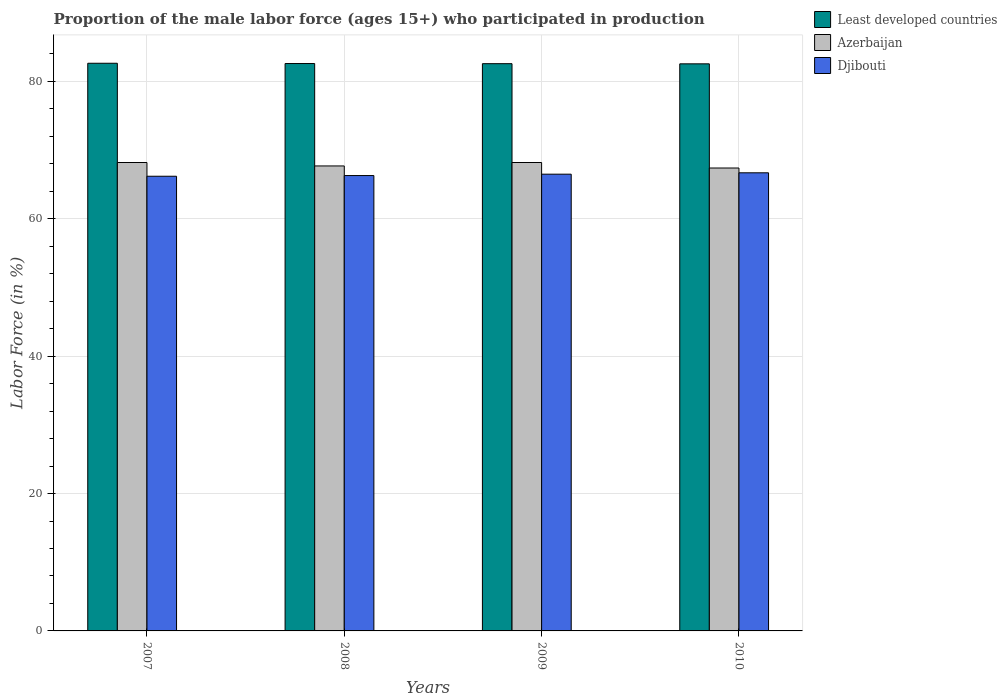How many groups of bars are there?
Provide a short and direct response. 4. Are the number of bars on each tick of the X-axis equal?
Make the answer very short. Yes. How many bars are there on the 1st tick from the left?
Provide a short and direct response. 3. What is the label of the 4th group of bars from the left?
Give a very brief answer. 2010. What is the proportion of the male labor force who participated in production in Least developed countries in 2008?
Provide a succinct answer. 82.61. Across all years, what is the maximum proportion of the male labor force who participated in production in Djibouti?
Keep it short and to the point. 66.7. Across all years, what is the minimum proportion of the male labor force who participated in production in Least developed countries?
Provide a succinct answer. 82.57. What is the total proportion of the male labor force who participated in production in Azerbaijan in the graph?
Ensure brevity in your answer.  271.5. What is the difference between the proportion of the male labor force who participated in production in Djibouti in 2009 and that in 2010?
Make the answer very short. -0.2. What is the difference between the proportion of the male labor force who participated in production in Azerbaijan in 2010 and the proportion of the male labor force who participated in production in Least developed countries in 2009?
Your response must be concise. -15.19. What is the average proportion of the male labor force who participated in production in Azerbaijan per year?
Keep it short and to the point. 67.87. What is the ratio of the proportion of the male labor force who participated in production in Least developed countries in 2007 to that in 2009?
Ensure brevity in your answer.  1. Is the proportion of the male labor force who participated in production in Djibouti in 2007 less than that in 2008?
Offer a terse response. Yes. Is the difference between the proportion of the male labor force who participated in production in Djibouti in 2007 and 2009 greater than the difference between the proportion of the male labor force who participated in production in Azerbaijan in 2007 and 2009?
Ensure brevity in your answer.  No. What is the difference between the highest and the second highest proportion of the male labor force who participated in production in Least developed countries?
Provide a succinct answer. 0.04. What is the difference between the highest and the lowest proportion of the male labor force who participated in production in Least developed countries?
Ensure brevity in your answer.  0.08. In how many years, is the proportion of the male labor force who participated in production in Least developed countries greater than the average proportion of the male labor force who participated in production in Least developed countries taken over all years?
Offer a terse response. 2. What does the 1st bar from the left in 2009 represents?
Ensure brevity in your answer.  Least developed countries. What does the 1st bar from the right in 2008 represents?
Make the answer very short. Djibouti. Is it the case that in every year, the sum of the proportion of the male labor force who participated in production in Djibouti and proportion of the male labor force who participated in production in Least developed countries is greater than the proportion of the male labor force who participated in production in Azerbaijan?
Offer a terse response. Yes. How many years are there in the graph?
Your answer should be compact. 4. Does the graph contain any zero values?
Keep it short and to the point. No. Does the graph contain grids?
Make the answer very short. Yes. What is the title of the graph?
Offer a very short reply. Proportion of the male labor force (ages 15+) who participated in production. Does "Costa Rica" appear as one of the legend labels in the graph?
Ensure brevity in your answer.  No. What is the Labor Force (in %) in Least developed countries in 2007?
Provide a succinct answer. 82.65. What is the Labor Force (in %) in Azerbaijan in 2007?
Ensure brevity in your answer.  68.2. What is the Labor Force (in %) of Djibouti in 2007?
Make the answer very short. 66.2. What is the Labor Force (in %) in Least developed countries in 2008?
Keep it short and to the point. 82.61. What is the Labor Force (in %) of Azerbaijan in 2008?
Offer a very short reply. 67.7. What is the Labor Force (in %) of Djibouti in 2008?
Give a very brief answer. 66.3. What is the Labor Force (in %) in Least developed countries in 2009?
Your answer should be very brief. 82.59. What is the Labor Force (in %) in Azerbaijan in 2009?
Ensure brevity in your answer.  68.2. What is the Labor Force (in %) of Djibouti in 2009?
Offer a terse response. 66.5. What is the Labor Force (in %) in Least developed countries in 2010?
Offer a terse response. 82.57. What is the Labor Force (in %) of Azerbaijan in 2010?
Your answer should be compact. 67.4. What is the Labor Force (in %) in Djibouti in 2010?
Offer a very short reply. 66.7. Across all years, what is the maximum Labor Force (in %) in Least developed countries?
Keep it short and to the point. 82.65. Across all years, what is the maximum Labor Force (in %) of Azerbaijan?
Provide a succinct answer. 68.2. Across all years, what is the maximum Labor Force (in %) in Djibouti?
Make the answer very short. 66.7. Across all years, what is the minimum Labor Force (in %) of Least developed countries?
Make the answer very short. 82.57. Across all years, what is the minimum Labor Force (in %) in Azerbaijan?
Your response must be concise. 67.4. Across all years, what is the minimum Labor Force (in %) of Djibouti?
Provide a succinct answer. 66.2. What is the total Labor Force (in %) of Least developed countries in the graph?
Give a very brief answer. 330.41. What is the total Labor Force (in %) of Azerbaijan in the graph?
Provide a succinct answer. 271.5. What is the total Labor Force (in %) of Djibouti in the graph?
Provide a succinct answer. 265.7. What is the difference between the Labor Force (in %) of Least developed countries in 2007 and that in 2008?
Your answer should be compact. 0.04. What is the difference between the Labor Force (in %) in Azerbaijan in 2007 and that in 2008?
Give a very brief answer. 0.5. What is the difference between the Labor Force (in %) of Djibouti in 2007 and that in 2008?
Offer a very short reply. -0.1. What is the difference between the Labor Force (in %) of Least developed countries in 2007 and that in 2009?
Your response must be concise. 0.06. What is the difference between the Labor Force (in %) in Azerbaijan in 2007 and that in 2009?
Offer a terse response. 0. What is the difference between the Labor Force (in %) of Djibouti in 2007 and that in 2009?
Keep it short and to the point. -0.3. What is the difference between the Labor Force (in %) of Least developed countries in 2007 and that in 2010?
Make the answer very short. 0.08. What is the difference between the Labor Force (in %) of Azerbaijan in 2007 and that in 2010?
Keep it short and to the point. 0.8. What is the difference between the Labor Force (in %) in Djibouti in 2007 and that in 2010?
Offer a terse response. -0.5. What is the difference between the Labor Force (in %) of Least developed countries in 2008 and that in 2009?
Your answer should be very brief. 0.02. What is the difference between the Labor Force (in %) in Least developed countries in 2008 and that in 2010?
Make the answer very short. 0.04. What is the difference between the Labor Force (in %) in Least developed countries in 2009 and that in 2010?
Keep it short and to the point. 0.02. What is the difference between the Labor Force (in %) in Azerbaijan in 2009 and that in 2010?
Keep it short and to the point. 0.8. What is the difference between the Labor Force (in %) of Djibouti in 2009 and that in 2010?
Give a very brief answer. -0.2. What is the difference between the Labor Force (in %) of Least developed countries in 2007 and the Labor Force (in %) of Azerbaijan in 2008?
Keep it short and to the point. 14.95. What is the difference between the Labor Force (in %) of Least developed countries in 2007 and the Labor Force (in %) of Djibouti in 2008?
Provide a succinct answer. 16.35. What is the difference between the Labor Force (in %) of Least developed countries in 2007 and the Labor Force (in %) of Azerbaijan in 2009?
Your answer should be compact. 14.45. What is the difference between the Labor Force (in %) of Least developed countries in 2007 and the Labor Force (in %) of Djibouti in 2009?
Keep it short and to the point. 16.15. What is the difference between the Labor Force (in %) of Azerbaijan in 2007 and the Labor Force (in %) of Djibouti in 2009?
Offer a very short reply. 1.7. What is the difference between the Labor Force (in %) in Least developed countries in 2007 and the Labor Force (in %) in Azerbaijan in 2010?
Your response must be concise. 15.25. What is the difference between the Labor Force (in %) in Least developed countries in 2007 and the Labor Force (in %) in Djibouti in 2010?
Your answer should be compact. 15.95. What is the difference between the Labor Force (in %) in Azerbaijan in 2007 and the Labor Force (in %) in Djibouti in 2010?
Make the answer very short. 1.5. What is the difference between the Labor Force (in %) of Least developed countries in 2008 and the Labor Force (in %) of Azerbaijan in 2009?
Provide a short and direct response. 14.41. What is the difference between the Labor Force (in %) in Least developed countries in 2008 and the Labor Force (in %) in Djibouti in 2009?
Give a very brief answer. 16.11. What is the difference between the Labor Force (in %) in Least developed countries in 2008 and the Labor Force (in %) in Azerbaijan in 2010?
Provide a succinct answer. 15.21. What is the difference between the Labor Force (in %) in Least developed countries in 2008 and the Labor Force (in %) in Djibouti in 2010?
Make the answer very short. 15.91. What is the difference between the Labor Force (in %) of Azerbaijan in 2008 and the Labor Force (in %) of Djibouti in 2010?
Offer a terse response. 1. What is the difference between the Labor Force (in %) of Least developed countries in 2009 and the Labor Force (in %) of Azerbaijan in 2010?
Your answer should be compact. 15.19. What is the difference between the Labor Force (in %) in Least developed countries in 2009 and the Labor Force (in %) in Djibouti in 2010?
Your answer should be very brief. 15.89. What is the average Labor Force (in %) in Least developed countries per year?
Your response must be concise. 82.6. What is the average Labor Force (in %) of Azerbaijan per year?
Give a very brief answer. 67.88. What is the average Labor Force (in %) in Djibouti per year?
Provide a short and direct response. 66.42. In the year 2007, what is the difference between the Labor Force (in %) of Least developed countries and Labor Force (in %) of Azerbaijan?
Make the answer very short. 14.45. In the year 2007, what is the difference between the Labor Force (in %) in Least developed countries and Labor Force (in %) in Djibouti?
Ensure brevity in your answer.  16.45. In the year 2007, what is the difference between the Labor Force (in %) in Azerbaijan and Labor Force (in %) in Djibouti?
Offer a terse response. 2. In the year 2008, what is the difference between the Labor Force (in %) in Least developed countries and Labor Force (in %) in Azerbaijan?
Your answer should be very brief. 14.91. In the year 2008, what is the difference between the Labor Force (in %) in Least developed countries and Labor Force (in %) in Djibouti?
Offer a very short reply. 16.31. In the year 2009, what is the difference between the Labor Force (in %) in Least developed countries and Labor Force (in %) in Azerbaijan?
Provide a succinct answer. 14.39. In the year 2009, what is the difference between the Labor Force (in %) of Least developed countries and Labor Force (in %) of Djibouti?
Provide a succinct answer. 16.09. In the year 2009, what is the difference between the Labor Force (in %) in Azerbaijan and Labor Force (in %) in Djibouti?
Provide a succinct answer. 1.7. In the year 2010, what is the difference between the Labor Force (in %) in Least developed countries and Labor Force (in %) in Azerbaijan?
Ensure brevity in your answer.  15.17. In the year 2010, what is the difference between the Labor Force (in %) in Least developed countries and Labor Force (in %) in Djibouti?
Provide a succinct answer. 15.87. In the year 2010, what is the difference between the Labor Force (in %) of Azerbaijan and Labor Force (in %) of Djibouti?
Make the answer very short. 0.7. What is the ratio of the Labor Force (in %) in Azerbaijan in 2007 to that in 2008?
Your answer should be very brief. 1.01. What is the ratio of the Labor Force (in %) of Djibouti in 2007 to that in 2008?
Offer a terse response. 1. What is the ratio of the Labor Force (in %) of Azerbaijan in 2007 to that in 2009?
Keep it short and to the point. 1. What is the ratio of the Labor Force (in %) of Azerbaijan in 2007 to that in 2010?
Give a very brief answer. 1.01. What is the ratio of the Labor Force (in %) in Least developed countries in 2008 to that in 2009?
Offer a terse response. 1. What is the ratio of the Labor Force (in %) of Azerbaijan in 2008 to that in 2009?
Your answer should be very brief. 0.99. What is the ratio of the Labor Force (in %) in Djibouti in 2008 to that in 2009?
Keep it short and to the point. 1. What is the ratio of the Labor Force (in %) of Azerbaijan in 2008 to that in 2010?
Your response must be concise. 1. What is the ratio of the Labor Force (in %) of Azerbaijan in 2009 to that in 2010?
Your answer should be very brief. 1.01. What is the difference between the highest and the second highest Labor Force (in %) in Least developed countries?
Your answer should be compact. 0.04. What is the difference between the highest and the second highest Labor Force (in %) in Djibouti?
Ensure brevity in your answer.  0.2. What is the difference between the highest and the lowest Labor Force (in %) in Least developed countries?
Provide a succinct answer. 0.08. What is the difference between the highest and the lowest Labor Force (in %) in Djibouti?
Offer a very short reply. 0.5. 